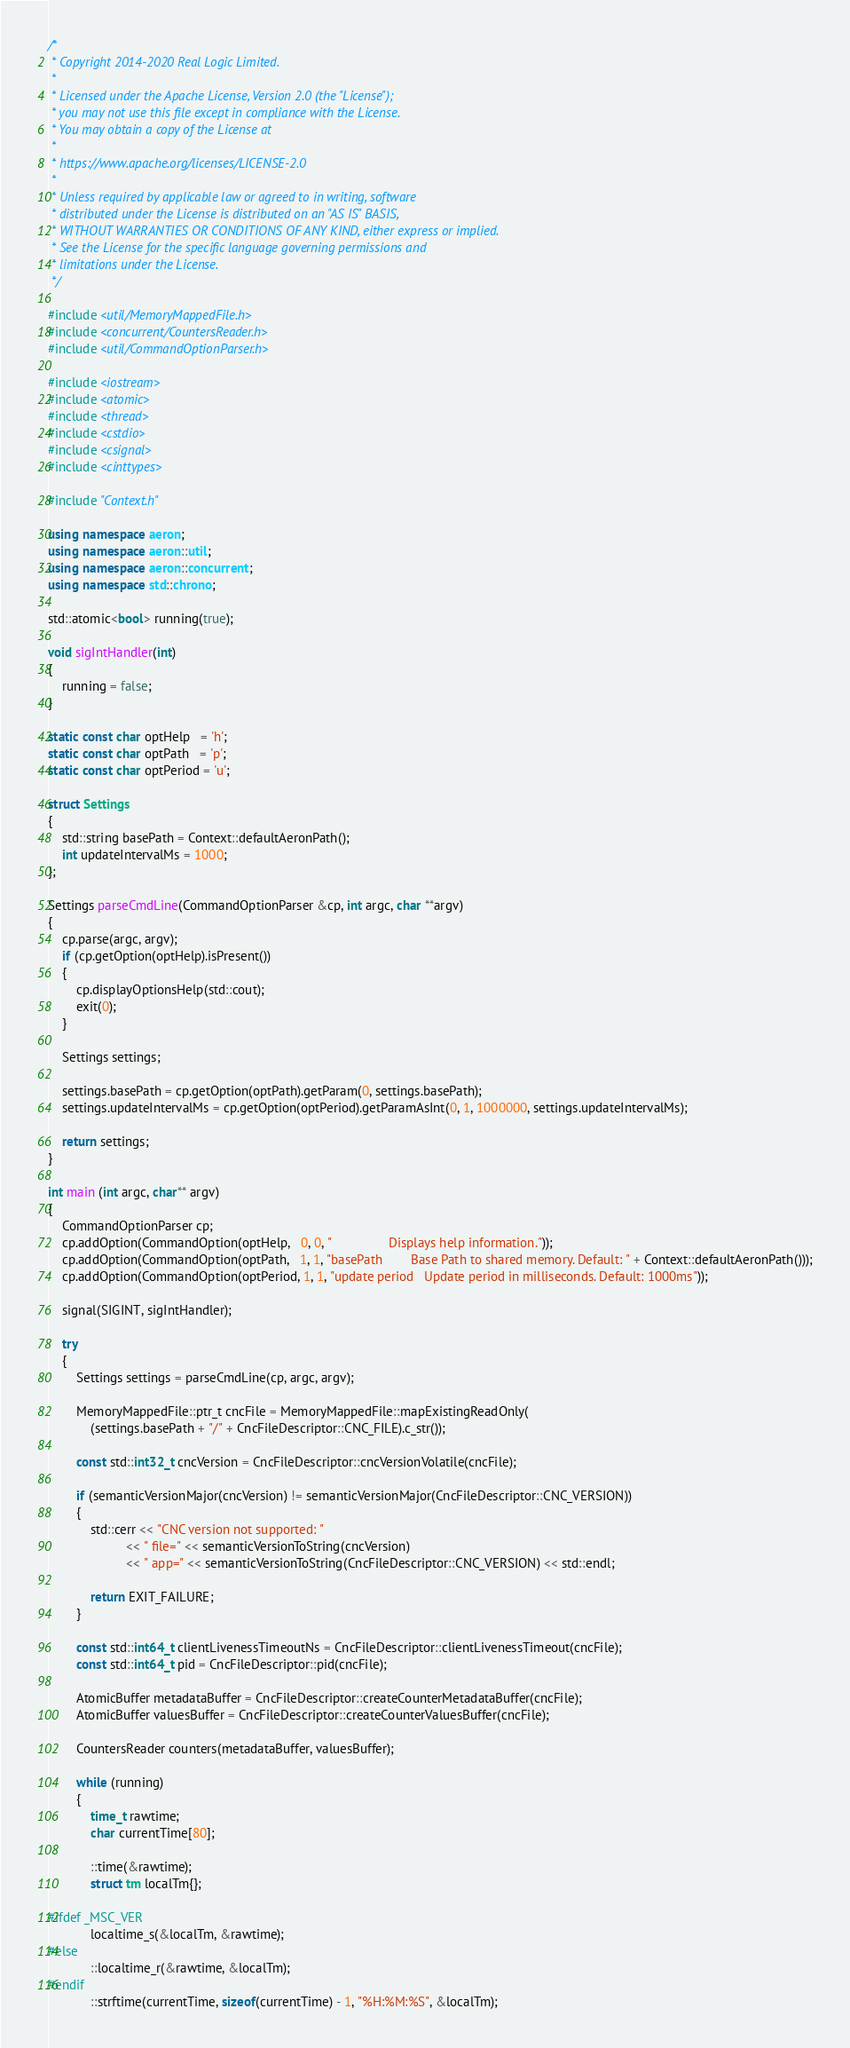Convert code to text. <code><loc_0><loc_0><loc_500><loc_500><_C++_>/*
 * Copyright 2014-2020 Real Logic Limited.
 *
 * Licensed under the Apache License, Version 2.0 (the "License");
 * you may not use this file except in compliance with the License.
 * You may obtain a copy of the License at
 *
 * https://www.apache.org/licenses/LICENSE-2.0
 *
 * Unless required by applicable law or agreed to in writing, software
 * distributed under the License is distributed on an "AS IS" BASIS,
 * WITHOUT WARRANTIES OR CONDITIONS OF ANY KIND, either express or implied.
 * See the License for the specific language governing permissions and
 * limitations under the License.
 */

#include <util/MemoryMappedFile.h>
#include <concurrent/CountersReader.h>
#include <util/CommandOptionParser.h>

#include <iostream>
#include <atomic>
#include <thread>
#include <cstdio>
#include <csignal>
#include <cinttypes>

#include "Context.h"

using namespace aeron;
using namespace aeron::util;
using namespace aeron::concurrent;
using namespace std::chrono;

std::atomic<bool> running(true);

void sigIntHandler(int)
{
    running = false;
}

static const char optHelp   = 'h';
static const char optPath   = 'p';
static const char optPeriod = 'u';

struct Settings
{
    std::string basePath = Context::defaultAeronPath();
    int updateIntervalMs = 1000;
};

Settings parseCmdLine(CommandOptionParser &cp, int argc, char **argv)
{
    cp.parse(argc, argv);
    if (cp.getOption(optHelp).isPresent())
    {
        cp.displayOptionsHelp(std::cout);
        exit(0);
    }

    Settings settings;

    settings.basePath = cp.getOption(optPath).getParam(0, settings.basePath);
    settings.updateIntervalMs = cp.getOption(optPeriod).getParamAsInt(0, 1, 1000000, settings.updateIntervalMs);

    return settings;
}

int main (int argc, char** argv)
{
    CommandOptionParser cp;
    cp.addOption(CommandOption(optHelp,   0, 0, "                Displays help information."));
    cp.addOption(CommandOption(optPath,   1, 1, "basePath        Base Path to shared memory. Default: " + Context::defaultAeronPath()));
    cp.addOption(CommandOption(optPeriod, 1, 1, "update period   Update period in milliseconds. Default: 1000ms"));

    signal(SIGINT, sigIntHandler);

    try
    {
        Settings settings = parseCmdLine(cp, argc, argv);

        MemoryMappedFile::ptr_t cncFile = MemoryMappedFile::mapExistingReadOnly(
            (settings.basePath + "/" + CncFileDescriptor::CNC_FILE).c_str());

        const std::int32_t cncVersion = CncFileDescriptor::cncVersionVolatile(cncFile);

        if (semanticVersionMajor(cncVersion) != semanticVersionMajor(CncFileDescriptor::CNC_VERSION))
        {
            std::cerr << "CNC version not supported: "
                      << " file=" << semanticVersionToString(cncVersion)
                      << " app=" << semanticVersionToString(CncFileDescriptor::CNC_VERSION) << std::endl;

            return EXIT_FAILURE;
        }

        const std::int64_t clientLivenessTimeoutNs = CncFileDescriptor::clientLivenessTimeout(cncFile);
        const std::int64_t pid = CncFileDescriptor::pid(cncFile);

        AtomicBuffer metadataBuffer = CncFileDescriptor::createCounterMetadataBuffer(cncFile);
        AtomicBuffer valuesBuffer = CncFileDescriptor::createCounterValuesBuffer(cncFile);

        CountersReader counters(metadataBuffer, valuesBuffer);

        while (running)
        {
            time_t rawtime;
            char currentTime[80];

            ::time(&rawtime);
            struct tm localTm{};

#ifdef _MSC_VER
            localtime_s(&localTm, &rawtime);
#else
            ::localtime_r(&rawtime, &localTm);
#endif
            ::strftime(currentTime, sizeof(currentTime) - 1, "%H:%M:%S", &localTm);
</code> 